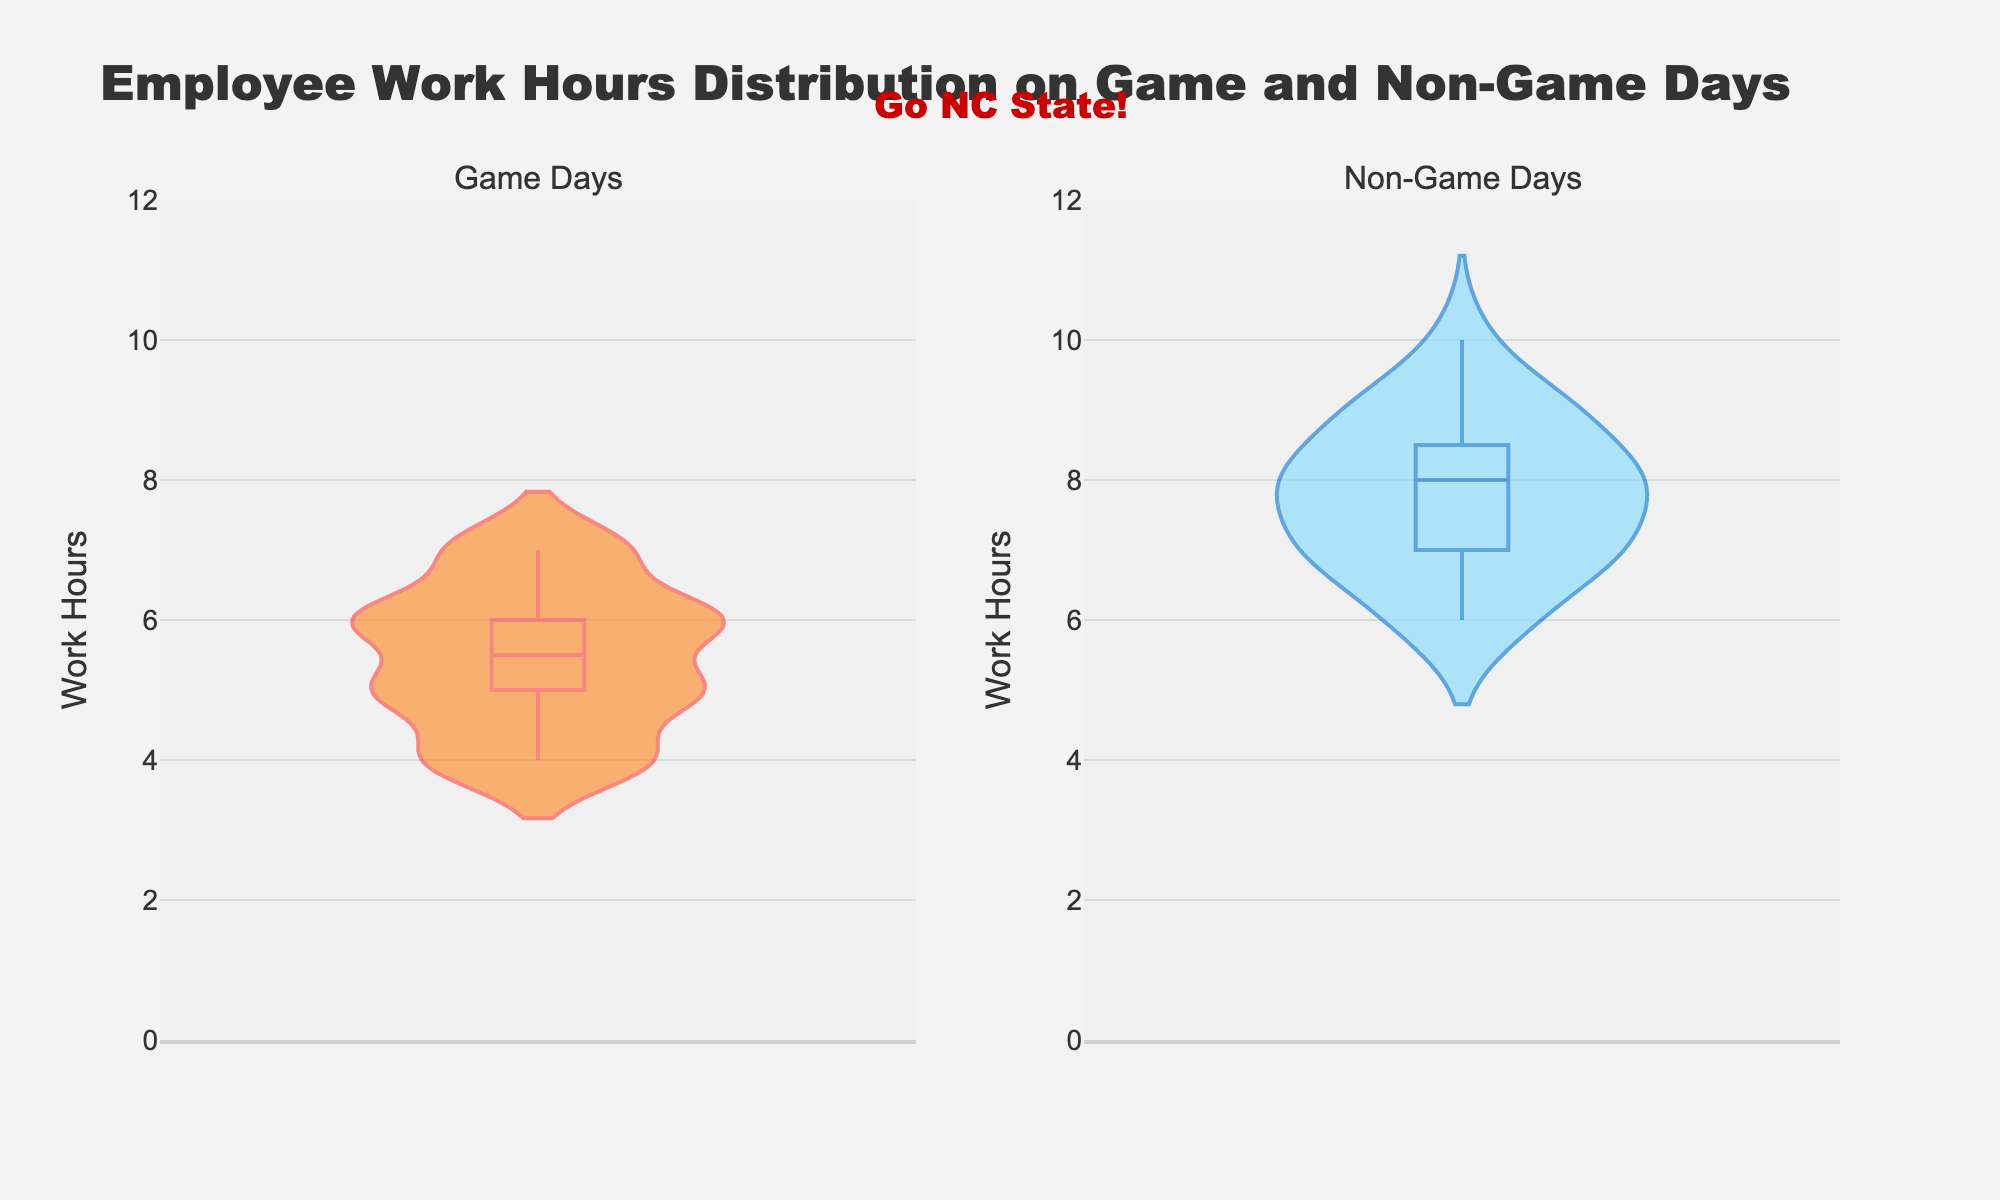How are the work hours distributed on game days? The violin chart for game days indicates a concentration of work hours around the central values. The spread of work hours is visualized by the width of the violin, with the box plot inside giving an exact idea of quartiles and median.
Answer: Work hours are mostly around 5-6 hours on game days How does the median work hours on game days compare to non-game days? To find this, we examine the central line in each violin plot, which represents the median. The median line on game days is lower compared to non-game days.
Answer: The median is lower on game days What is the maximum work hours observed on non-game days? By looking at the top edges of the violin plot for non-game days, we observe that the maximum work hours data point reaches up to 10 hours.
Answer: 10 hours How does the range of work hours on game days compare to non-game days? The range of work hours can be seen by the spread from the bottom to the top of each violin plot. Game days have a range from 4 to 7 hours, while non-game days range from 6 to 10 hours.
Answer: It is smaller on game days Which days have a more spread out distribution of work hours? The width and spread of the violins indicate the distribution. The violin for non-game days is wider, indicating a more spread out distribution.
Answer: Non-game days What is the interquartile range (IQR) for work hours on non-game days? The IQR is the range between the first and third quartiles in the box plot inside the violin. Visually, the middle 50% of the data for non-game days spreads from 7 to 8.5 hours.
Answer: 1.5 hours Do game days or non-game days have more consistent work hours among employees? Consistency is indicated by a narrower and denser violin plot. Game days have a denser and narrower distribution compared to non-game days.
Answer: Game days Are there any outliers in the data? Outliers would appear as single dots or thin lines far from the bulk of the data in the violin plot. Neither game day nor non-game day distributions show distinct outliers.
Answer: No outliers What is the mean value of work hours on non-game days? Mean can be approximated by the central tendency of the data in the violin plot, and considering 6 to 10 hours spread with a denser center, averaging around 8 hours.
Answer: Approximately 8 hours 